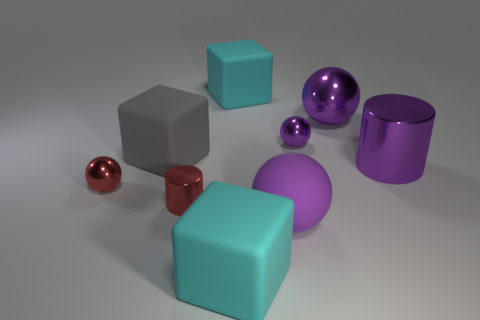Subtract all purple balls. How many were subtracted if there are1purple balls left? 2 Subtract all red cylinders. How many purple spheres are left? 3 Add 1 big purple shiny cylinders. How many objects exist? 10 Subtract all cubes. How many objects are left? 6 Add 1 purple rubber spheres. How many purple rubber spheres are left? 2 Add 6 big purple matte blocks. How many big purple matte blocks exist? 6 Subtract 0 brown cylinders. How many objects are left? 9 Subtract all large blocks. Subtract all cyan things. How many objects are left? 4 